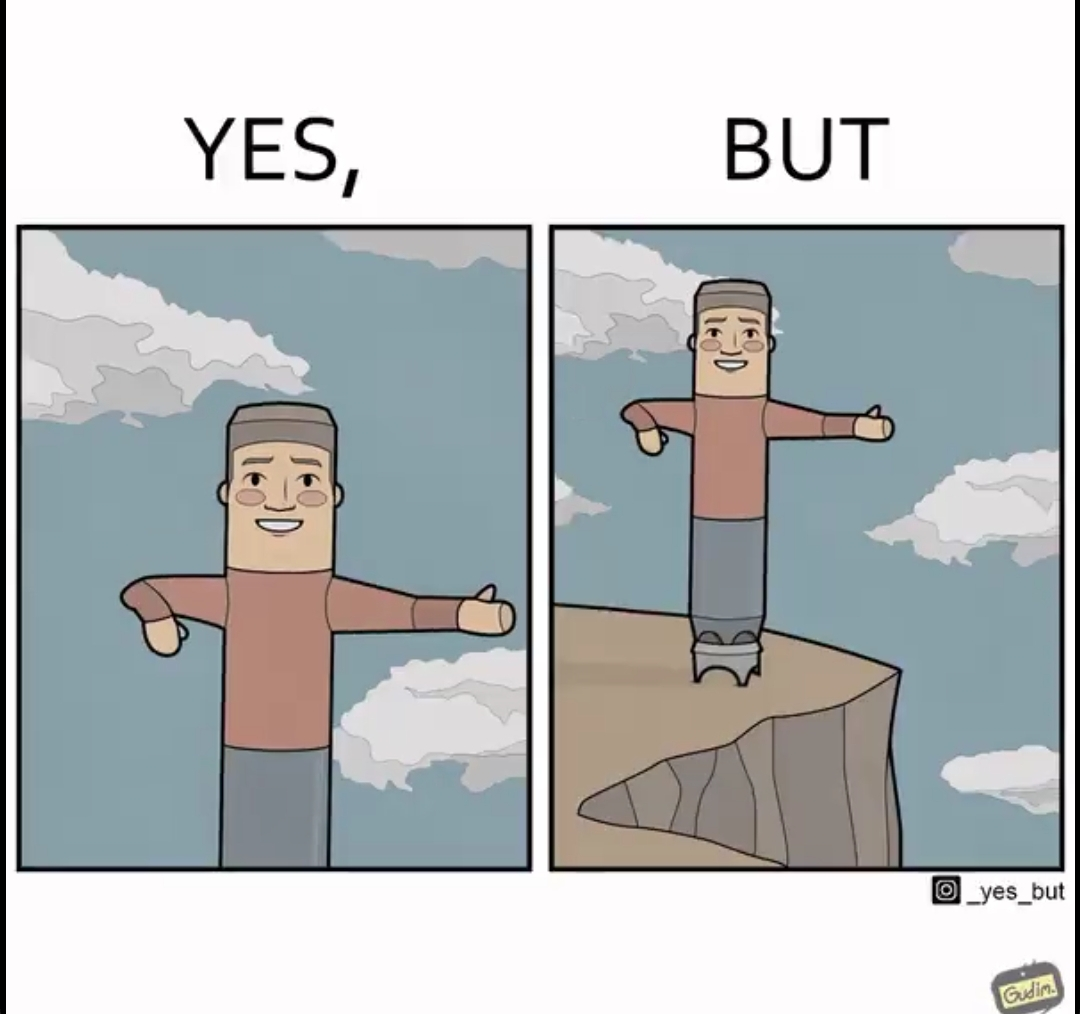Does this image contain satire or humor? Yes, this image is satirical. 